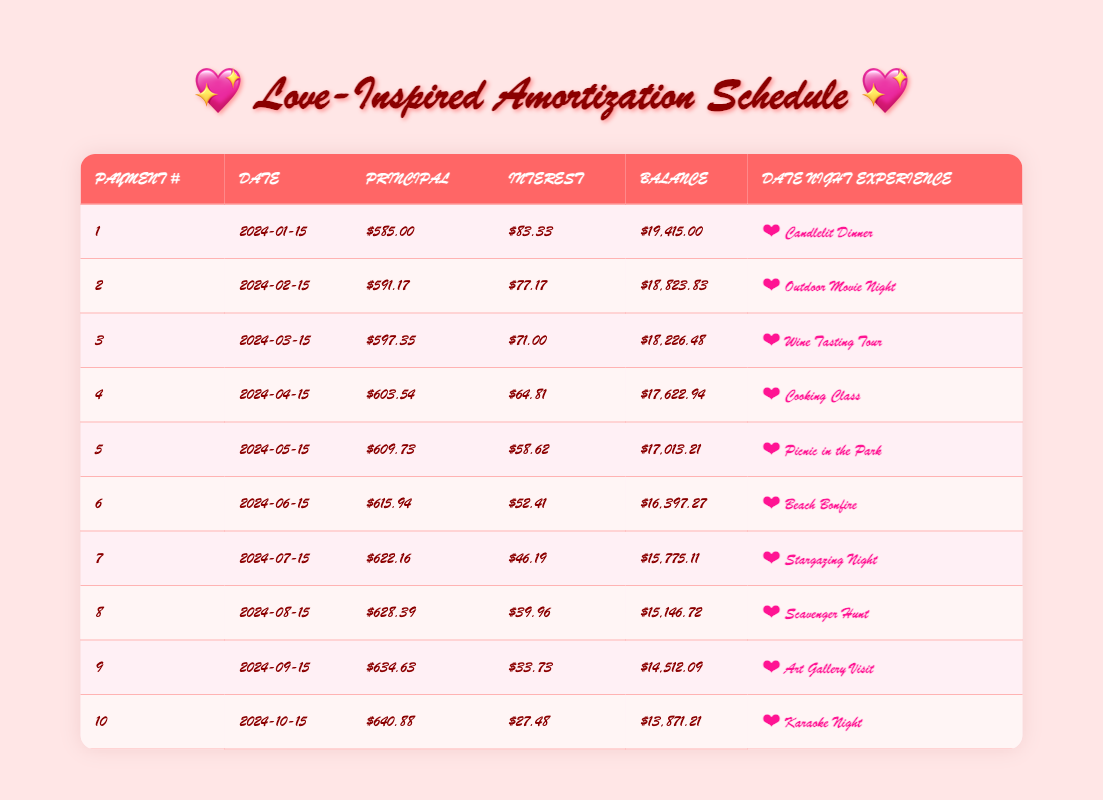What is the amount of the first principal payment? The first principal payment is found in the "Principal" column of the first row of the table, which shows $585.00.
Answer: $585.00 What is the interest payment for the second month? The interest payment for the second month can be found in the "Interest" column of the second row in the table, which shows $77.17.
Answer: $77.17 How much is the remaining balance after the fifth payment? The remaining balance after the fifth payment is listed in the "Balance" column of the fifth row, which shows $17,013.21.
Answer: $17,013.21 What is the total principal payment made after the first three payments? To find the total principal payment for the first three payments, add the principal payments from the first three rows: $585.00 + $591.17 + $597.35 = $1,773.52.
Answer: $1,773.52 Is the principal payment for the seventh month greater than the principal payment for the fourth month? The principal payment for the seventh month is $622.16, and for the fourth month, it is $603.54. Since $622.16 is greater than $603.54, the statement is true.
Answer: Yes What is the average interest payment for the first five months? To find the average interest payment for the first five months, add the interest payments: $83.33 + $77.17 + $71.00 + $64.81 + $58.62 = $354.93. Then divide by 5: $354.93 / 5 = $70.986, which rounds to $70.99.
Answer: $70.99 How much was the principal paid in the last payment compared to the total principal paid after the first four payments? The last payment's principal is $640.88, and total principal for the first four is $585.00 + $591.17 + $597.35 + $603.54 = $2,377.06. The last payment is greater than the total of the first four payments.
Answer: Greater What is the total number of date night experiences planned in the first ten payments? Counting the unique experiences listed in the "Date Night Experience" column for the first ten payments, there are ten planned experiences.
Answer: 10 What is the remaining balance after six payments? The remaining balance after six payments is found in the "Balance" column of the sixth row, which shows $16,397.27.
Answer: $16,397.27 